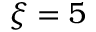Convert formula to latex. <formula><loc_0><loc_0><loc_500><loc_500>\xi = 5</formula> 